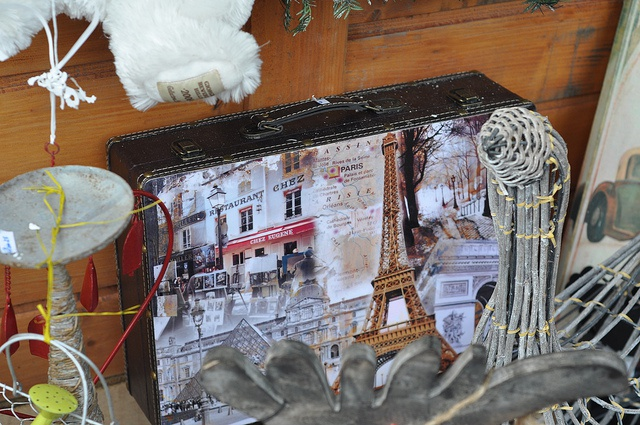Describe the objects in this image and their specific colors. I can see a suitcase in lightgray, black, gray, maroon, and darkgray tones in this image. 